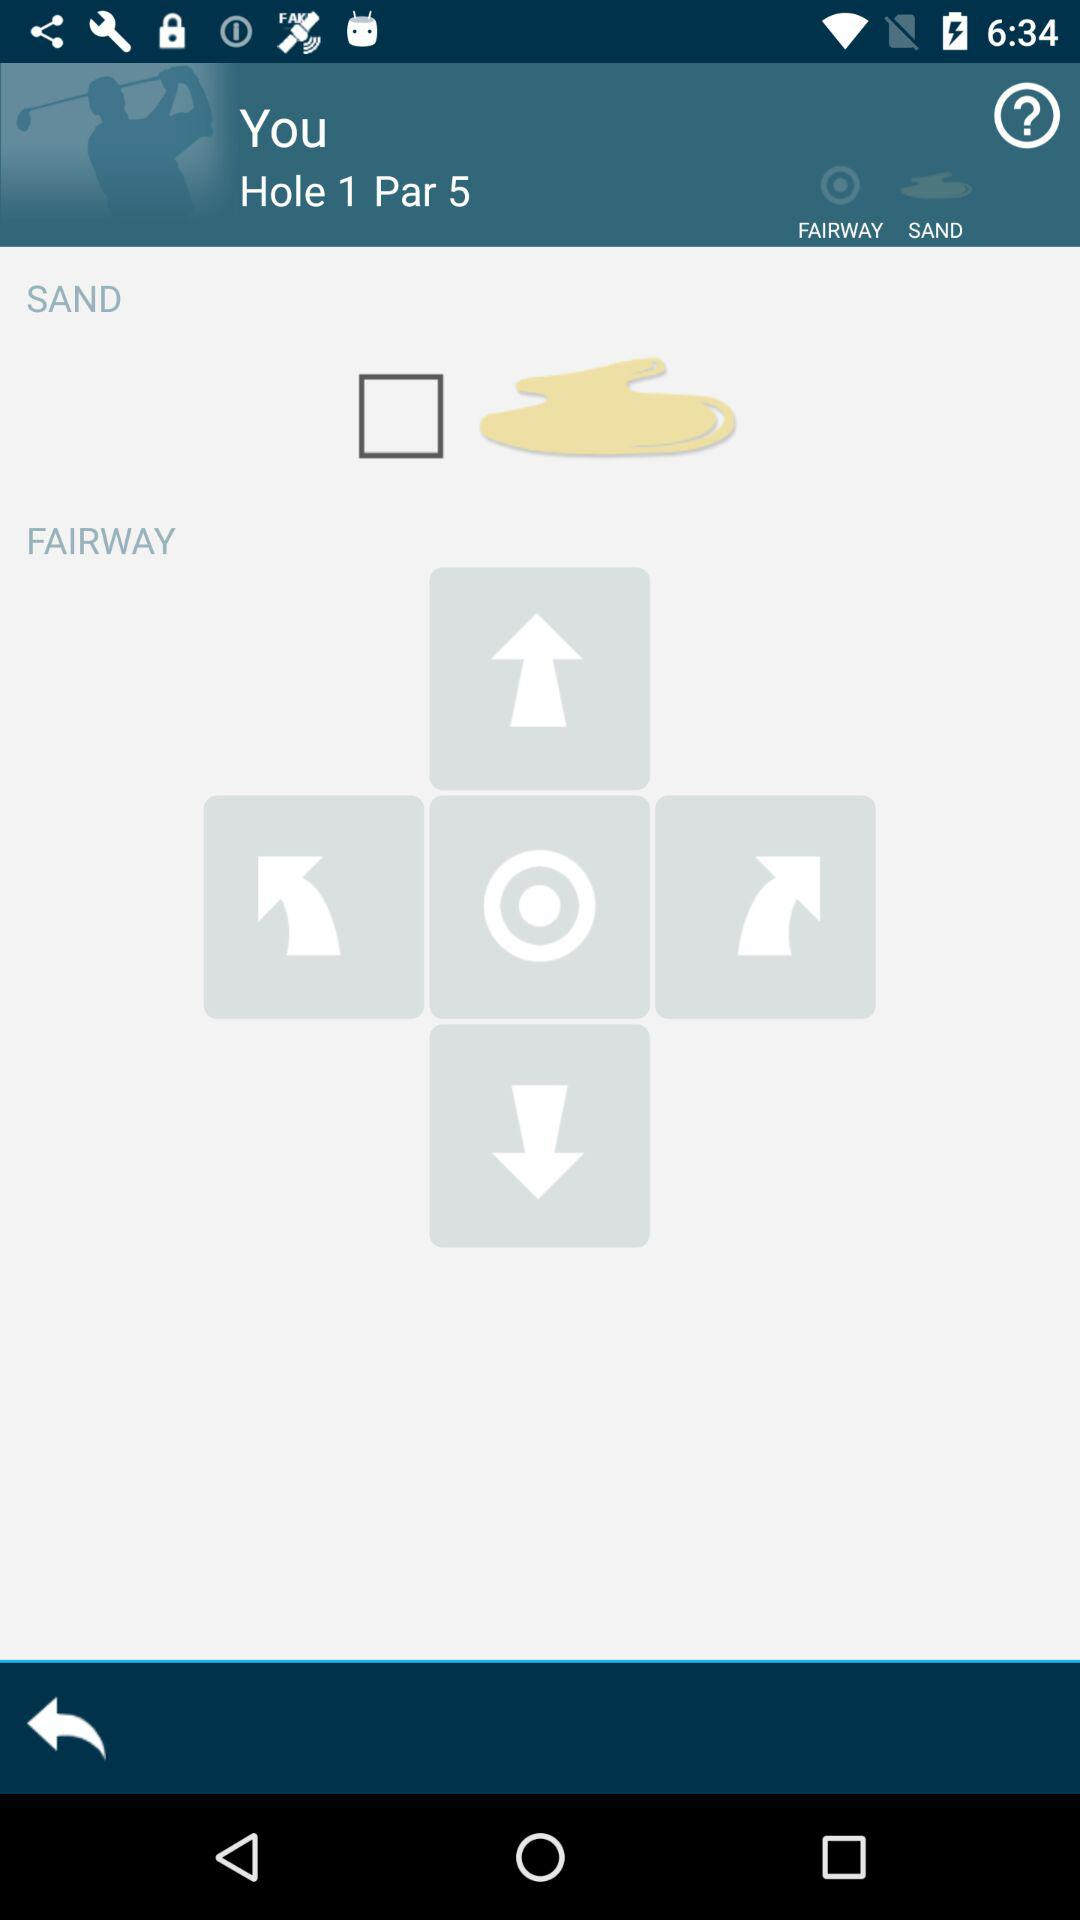What is the number of par? The number of par is 5. 